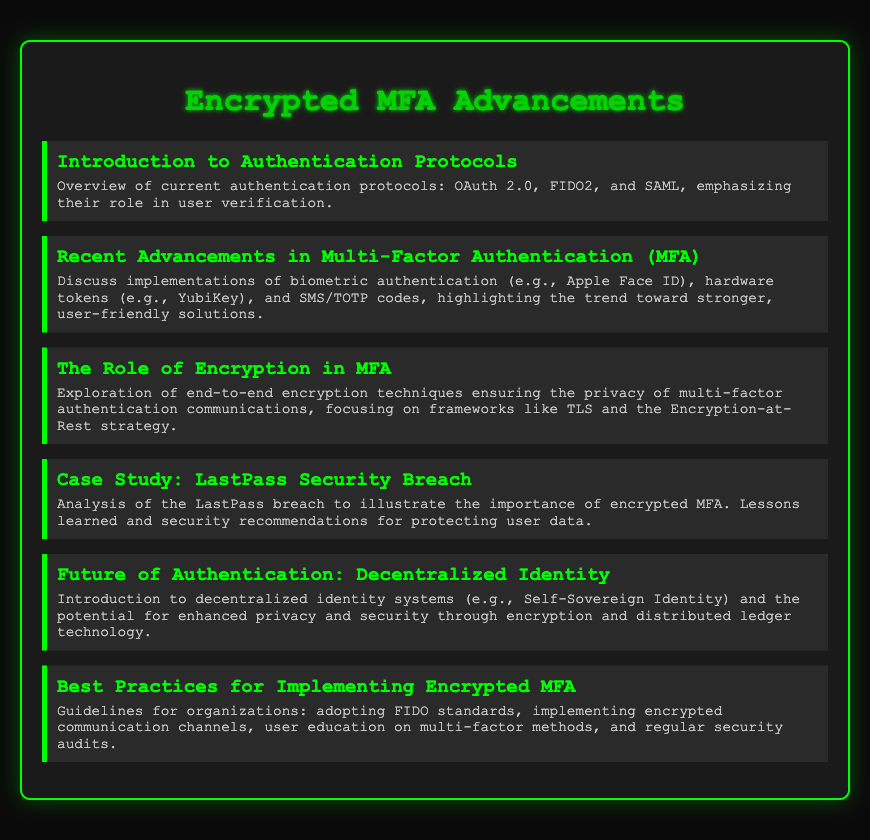What are the current authentication protocols mentioned? The document lists OAuth 2.0, FIDO2, and SAML as the current authentication protocols.
Answer: OAuth 2.0, FIDO2, SAML What biometric authentication implementation is highlighted? The presentation mentions Apple Face ID as a biometric authentication implementation.
Answer: Apple Face ID What is emphasized about multi-factor authentication communications? The document emphasizes the importance of end-to-end encryption techniques for the privacy of communications.
Answer: End-to-end encryption What case study is used to illustrate the importance of encrypted MFA? The presentation analyzes the LastPass breach as a case study for the importance of encrypted MFA.
Answer: LastPass breach What is the potential benefit of decentralized identity systems? The document suggests that decentralized identity systems may provide enhanced privacy and security.
Answer: Enhanced privacy and security What standard is recommended for organizations implementing encrypted MFA? The document recommends organizations adopt FIDO standards as a best practice.
Answer: FIDO standards 